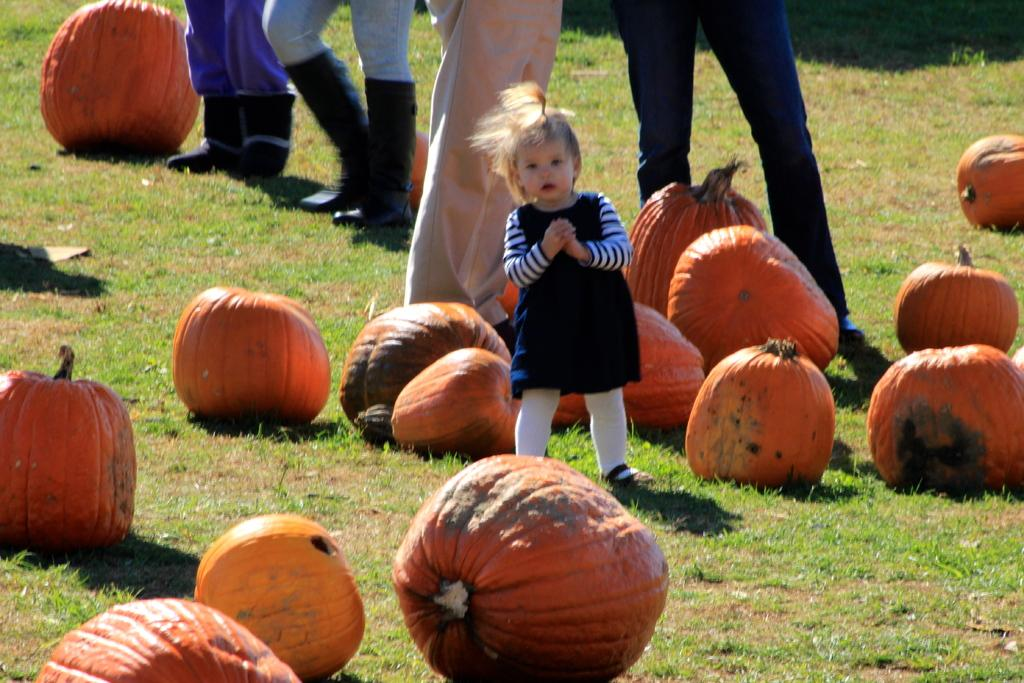What is the main subject of the image? There is a baby in the image. Where is the baby standing? The baby is standing on grassland. What other objects can be seen in the image? There are pumpkins in the image. How are the pumpkins distributed in the image? The pumpkins are scattered all over the place. Can you describe the people in the background of the image? There are people standing in the background of the image. What type of bubble can be seen floating near the baby in the image? There is no bubble present in the image. 